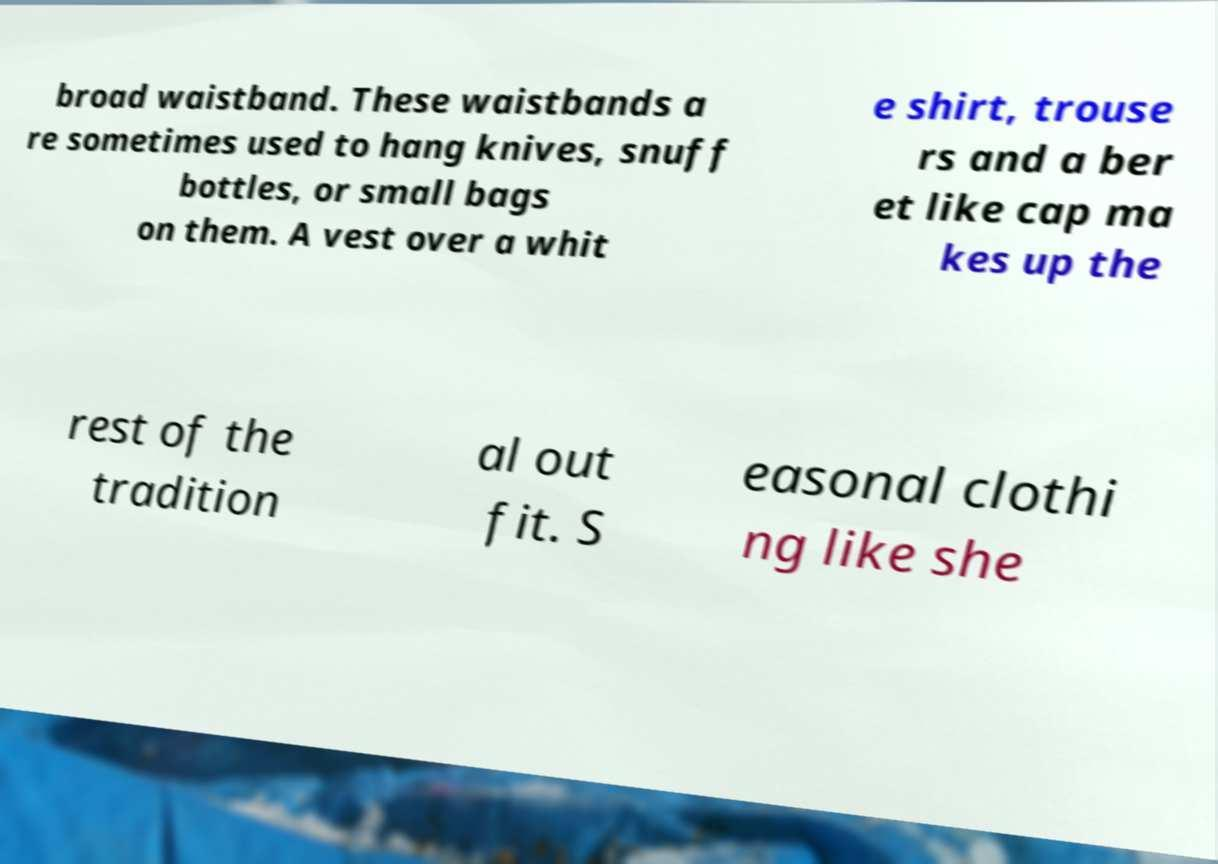I need the written content from this picture converted into text. Can you do that? broad waistband. These waistbands a re sometimes used to hang knives, snuff bottles, or small bags on them. A vest over a whit e shirt, trouse rs and a ber et like cap ma kes up the rest of the tradition al out fit. S easonal clothi ng like she 